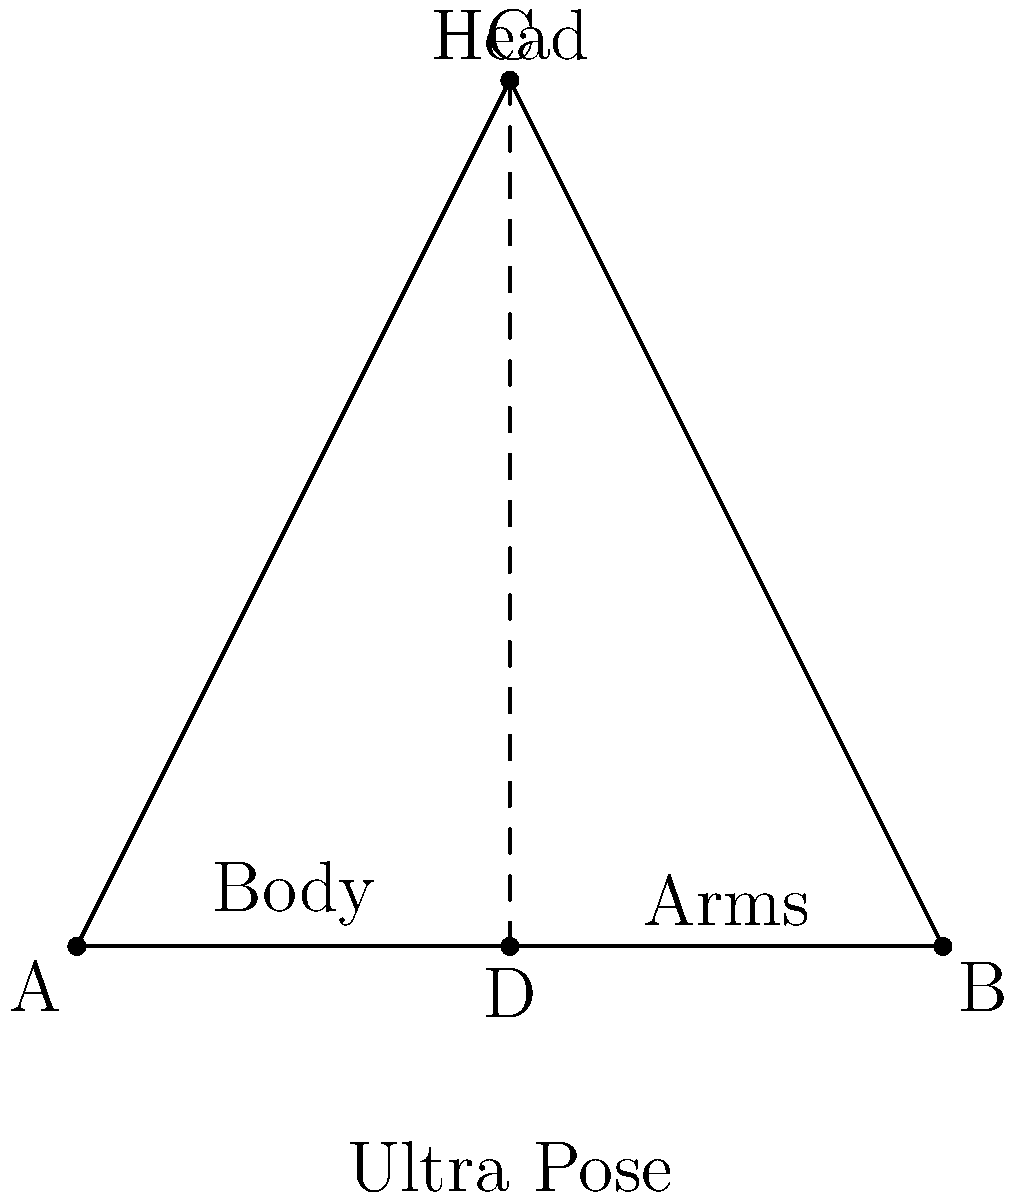In the Ultra Series, many Ultramen perform a distinctive transformation pose. If we represent this pose as a triangle ABC with a vertical line from C to D on AB, which geometric principle is demonstrated by the congruence of triangles ACD and BCD? To determine the congruence of triangles ACD and BCD, let's follow these steps:

1. Observe that CD is a common side to both triangles ACD and BCD.

2. Note that CD is perpendicular to AB, as it represents the vertical line in the Ultra pose.

3. Since CD is perpendicular to AB and D is the midpoint of AB (representing the center of the body), we can conclude that:
   - Angle ACD = Angle BCD = 90° (right angles)
   - AD = BD (D is the midpoint of AB)

4. Now we have:
   - CD is common to both triangles
   - Angle ACD = Angle BCD = 90°
   - AD = BD

5. This satisfies the Right Angle-Hypotenuse-Side (RHS) congruence criterion, which states that if the hypotenuse and one side of a right-angled triangle are equal to the hypotenuse and one side of another right-angled triangle, the two triangles are congruent.

Therefore, triangles ACD and BCD are congruent by the RHS congruence criterion, which is demonstrated in this representation of the Ultra transformation pose.
Answer: RHS (Right Angle-Hypotenuse-Side) Congruence 